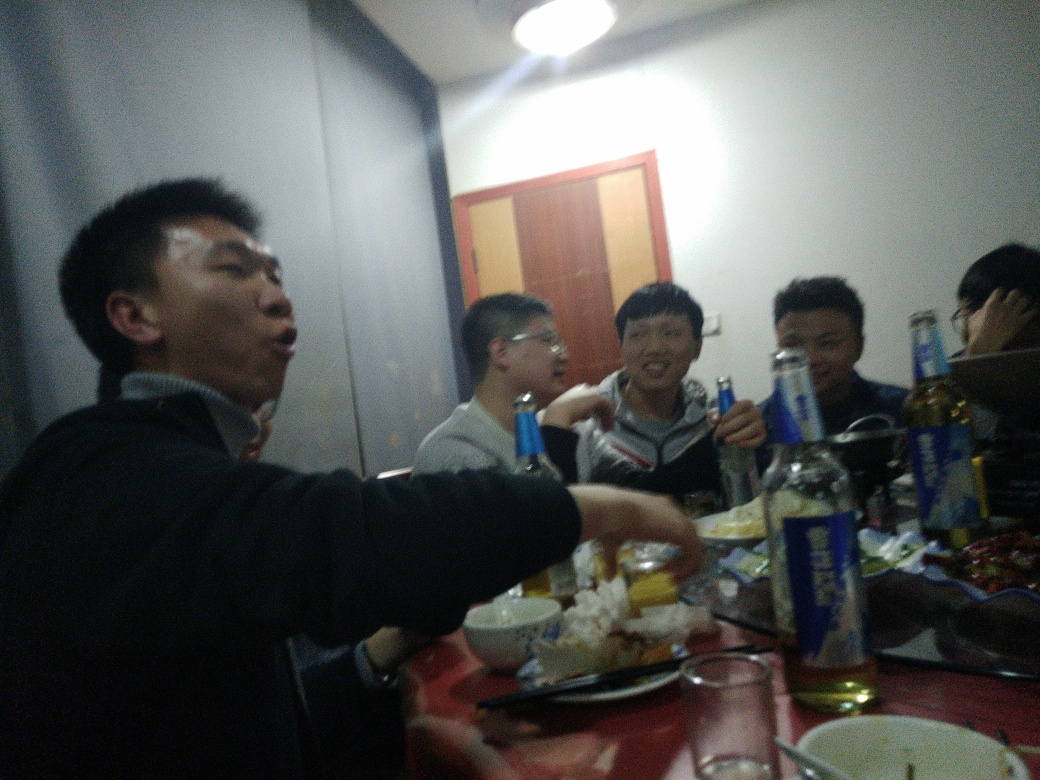Why is the quality of this image poor? The quality of this image is poor due to several factors, including an overall low level of clarity, where finer texture details are lost, and a prevalence of visual noise which can be seen as a grainy or pixelated quality. The image has low contrast, meaning the difference between the light and dark areas is not very pronounced, which contributes to an image that appears flat or washed out. The colors are not vibrant and can be described as unremarkable. This quality assessment aligns with option D, which accurately describes the visual deficiencies in the image. 